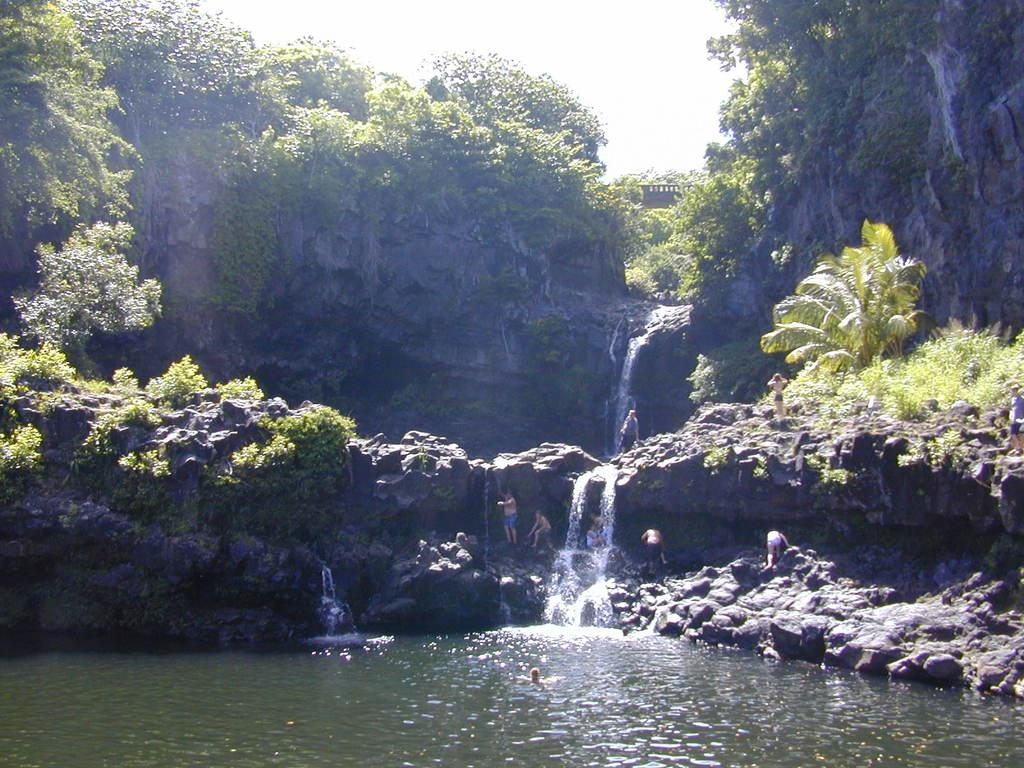What is at the bottom of the image? There is water at the bottom of the image. What are the people in the image doing? The people are standing on stones in the center of the image. What can be seen in the background of the image? The image appears to depict mountains in the background, along with a waterfall and the sky. What type of texture can be seen on the needle in the image? There is no needle present in the image. How does the water roll down the rocks in the image? The water does not roll down the rocks in the image; it is stationary at the bottom. 